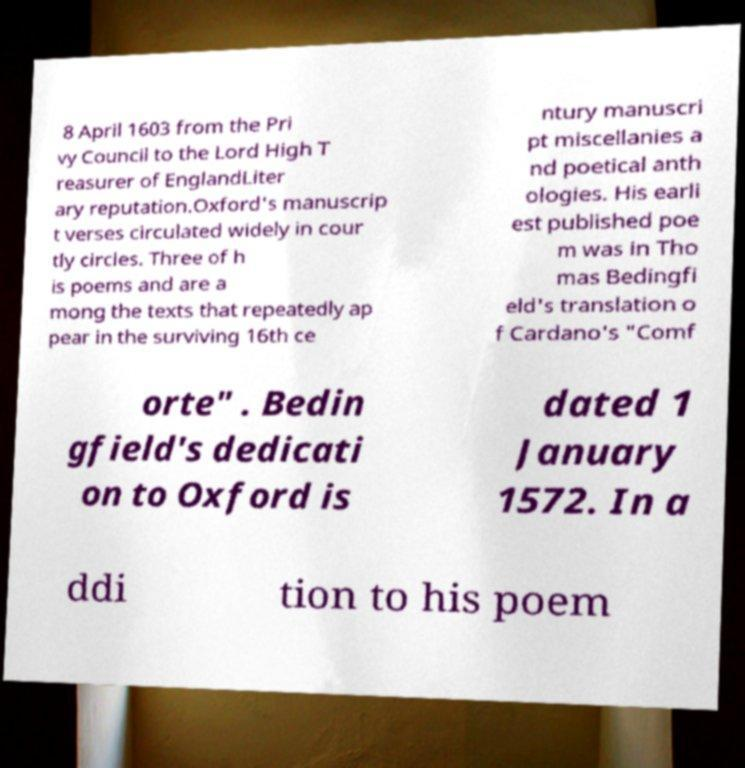What messages or text are displayed in this image? I need them in a readable, typed format. 8 April 1603 from the Pri vy Council to the Lord High T reasurer of EnglandLiter ary reputation.Oxford's manuscrip t verses circulated widely in cour tly circles. Three of h is poems and are a mong the texts that repeatedly ap pear in the surviving 16th ce ntury manuscri pt miscellanies a nd poetical anth ologies. His earli est published poe m was in Tho mas Bedingfi eld's translation o f Cardano's "Comf orte" . Bedin gfield's dedicati on to Oxford is dated 1 January 1572. In a ddi tion to his poem 